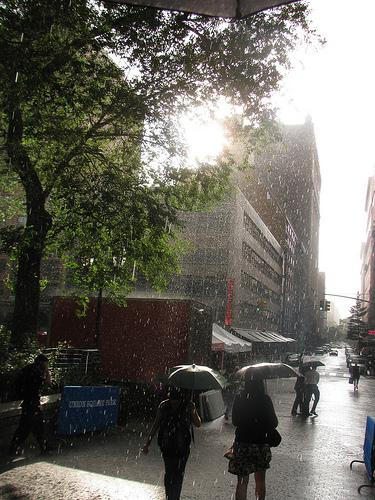Determine which traffic light color is visible in the image and where it is located. A green light is visible on the traffic fixture at the intersection. Identify the different types and colors of umbrellas held by the people in the image. There are black umbrellas, and two women holding open umbrellas. The color of the women's umbrellas is not specified. What objects can you infer are meant for navigating the rainy weather in the image? Umbrellas are being used to navigate the rainy weather in the image. State the number of objects with the keyword "umbrella" in the image and their respective captions. There are 6 objects: two women holding open umbrellas, a couple sharing one umbrella, black umbrella held up (x2), woman carrying an umbrella, person carrying an umbrella. Please provide a brief description of the scenery in the image. The image shows a rainy city street with people walking and carrying umbrellas, cars parked on both sides, and a traffic light at an intersection. Explain how the individuals are interacting with their environment in this picture. People are walking on the sidewalk or near cars, holding umbrellas to shield from the rain, and are navigating a wet city street. Describe the location where the image takes place and the weather condition at that time. The image is set in a city street during a rainy day with wet sidewalks. What is happening with the people during this rainy day? People are walking in the rain, holding umbrellas, and some are sharing an umbrella, while a woman near the cars does not have one. List down the total number of objects present in the image that have descriptions. There are 28 objects with descriptions. Give a sentimental analysis of the image based on the presence of people, objects, and events. The image evokes a calm, quiet atmosphere with people carrying on their daily routine during a rainy day in a city scene. 